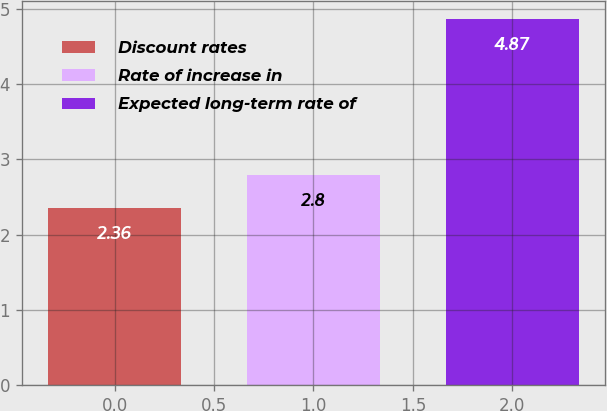Convert chart. <chart><loc_0><loc_0><loc_500><loc_500><bar_chart><fcel>Discount rates<fcel>Rate of increase in<fcel>Expected long-term rate of<nl><fcel>2.36<fcel>2.8<fcel>4.87<nl></chart> 